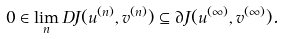Convert formula to latex. <formula><loc_0><loc_0><loc_500><loc_500>0 \in \lim _ { n } D J ( u ^ { ( n ) } , v ^ { ( n ) } ) \subseteq \partial J ( u ^ { ( \infty ) } , v ^ { ( \infty ) } ) .</formula> 